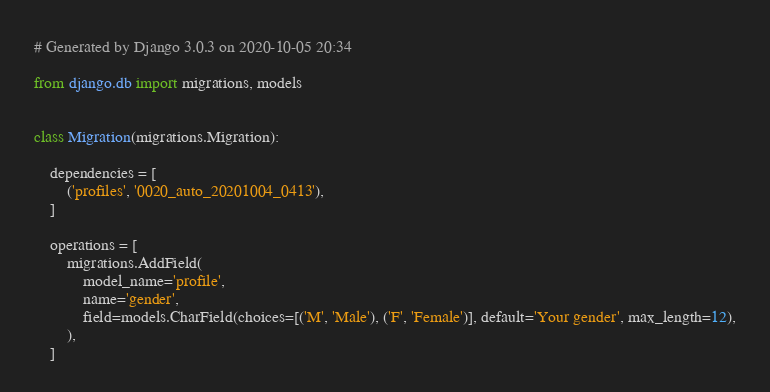<code> <loc_0><loc_0><loc_500><loc_500><_Python_># Generated by Django 3.0.3 on 2020-10-05 20:34

from django.db import migrations, models


class Migration(migrations.Migration):

    dependencies = [
        ('profiles', '0020_auto_20201004_0413'),
    ]

    operations = [
        migrations.AddField(
            model_name='profile',
            name='gender',
            field=models.CharField(choices=[('M', 'Male'), ('F', 'Female')], default='Your gender', max_length=12),
        ),
    ]
</code> 